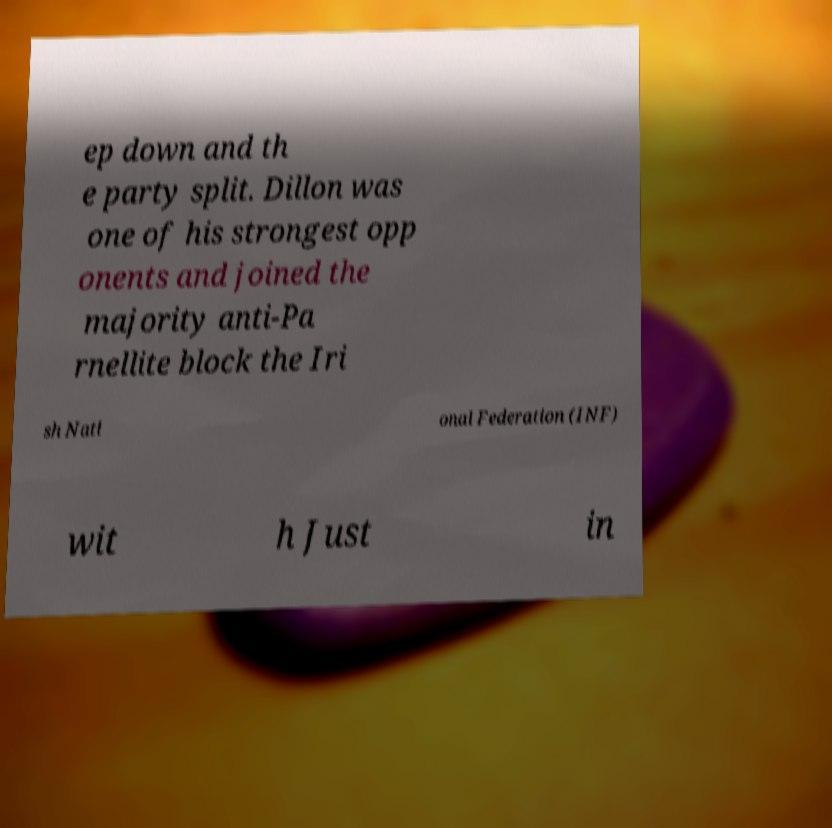What messages or text are displayed in this image? I need them in a readable, typed format. ep down and th e party split. Dillon was one of his strongest opp onents and joined the majority anti-Pa rnellite block the Iri sh Nati onal Federation (INF) wit h Just in 